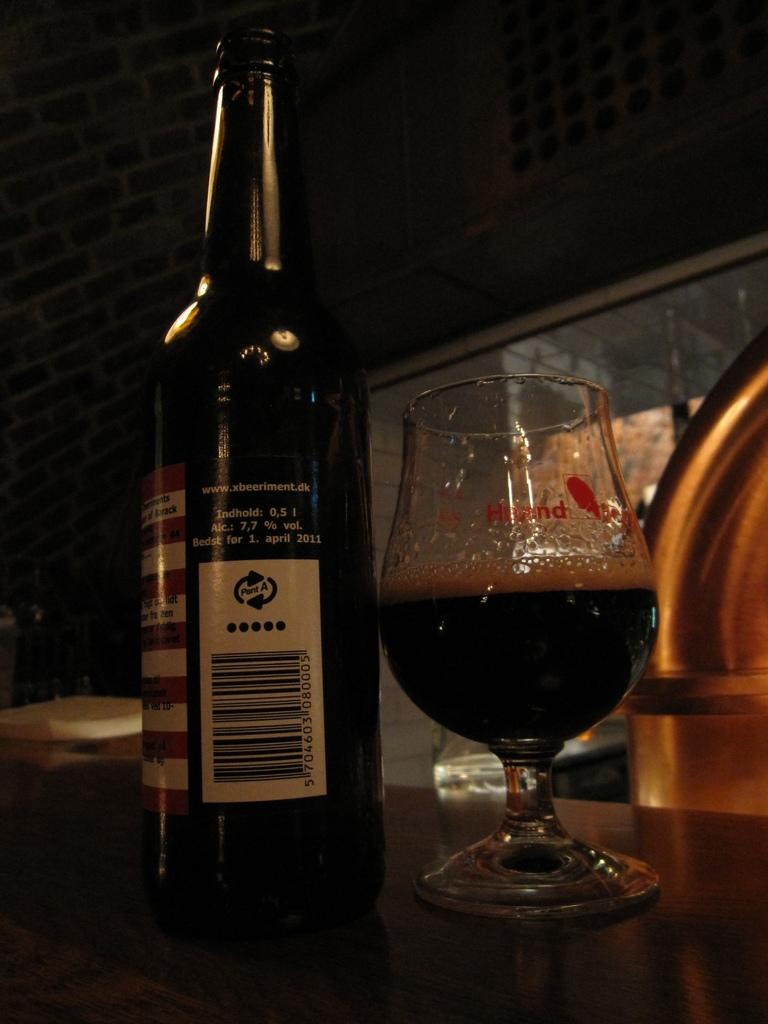What can be seen in the image that is used for holding liquids? There is a bottle and a glass with a drink in it in the image. Where are the bottle and glass located? The bottle and glass are on a platform in the image. What can be seen in the background of the image? There is a wall and unspecified objects in the background of the image. What type of leather material can be seen on the squirrel in the image? There is no squirrel present in the image, and therefore no leather material can be observed. 